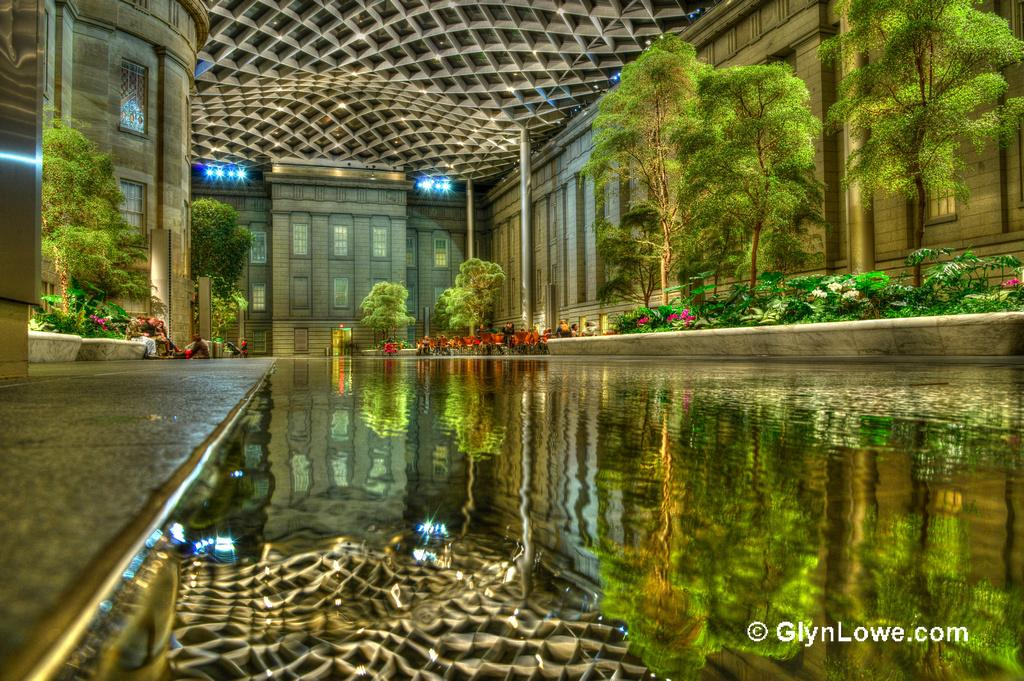What is the primary element visible in the image? There is water in the image. What type of structures can be seen in the image? There are buildings in the image. What type of vegetation is present in the image? There are trees in the image. What part of a building is visible in the image? There is a roof in the image. What type of spark can be seen coming from the trees in the image? There is no spark present in the image; it features water, buildings, trees, and a roof. What type of blade is being used to cut the quince in the image? There is no quince or blade present in the image. 